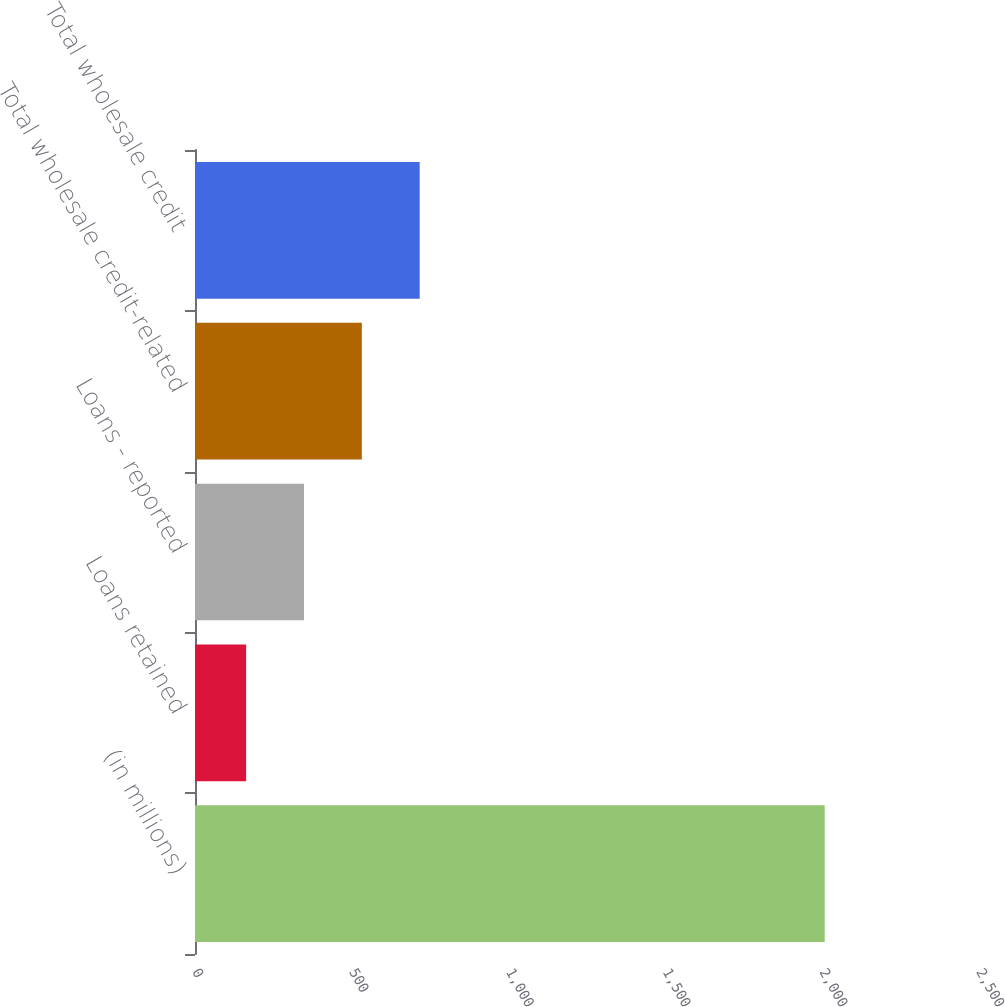Convert chart. <chart><loc_0><loc_0><loc_500><loc_500><bar_chart><fcel>(in millions)<fcel>Loans retained<fcel>Loans - reported<fcel>Total wholesale credit-related<fcel>Total wholesale credit<nl><fcel>2008<fcel>163<fcel>347.5<fcel>532<fcel>716.5<nl></chart> 